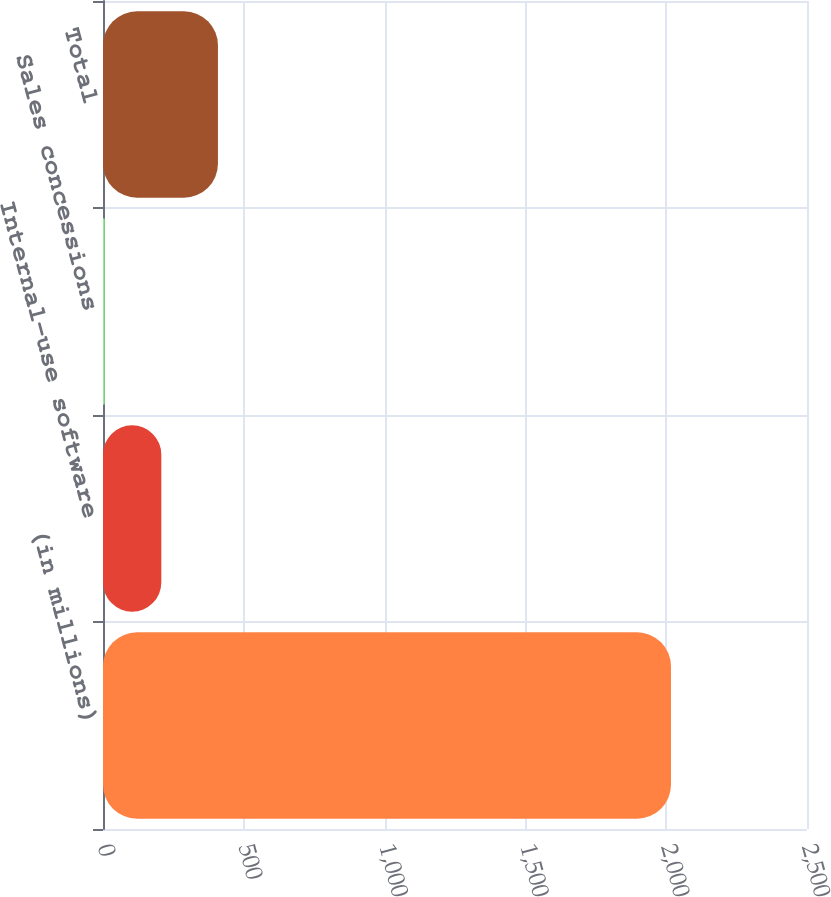<chart> <loc_0><loc_0><loc_500><loc_500><bar_chart><fcel>(in millions)<fcel>Internal-use software<fcel>Sales concessions<fcel>Total<nl><fcel>2017<fcel>207.1<fcel>6<fcel>408.2<nl></chart> 